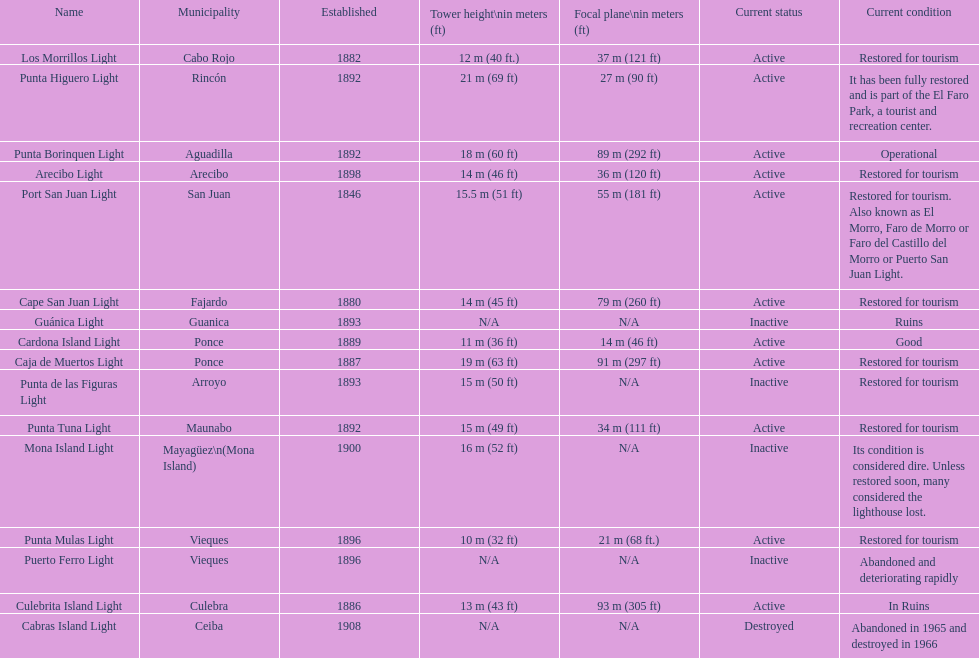What is the count of lighthouses with names that start with a "p"? 7. 